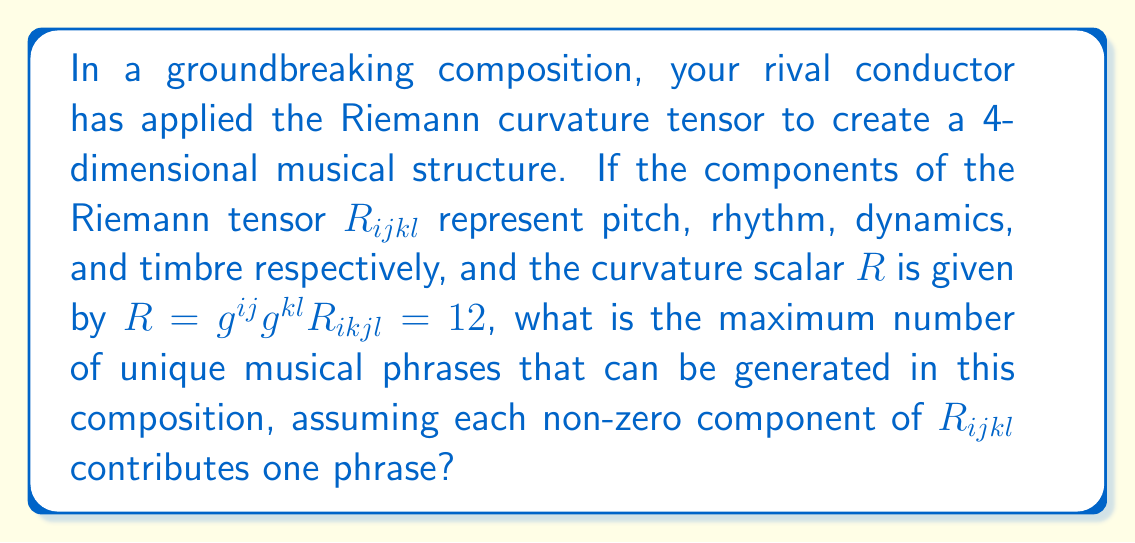Can you solve this math problem? To solve this problem, we need to follow these steps:

1) Recall that the Riemann curvature tensor $R_{ijkl}$ in 4 dimensions has 256 components (4^4).

2) However, due to the symmetries of the Riemann tensor:
   $R_{ijkl} = -R_{jikl} = -R_{ijlk} = R_{klij}$

3) These symmetries reduce the number of independent components to:
   $\frac{1}{12}n^2(n^2-1)$ where n is the dimension (4 in this case).

4) Calculate the number of independent components:
   $\frac{1}{12}4^2(4^2-1) = \frac{1}{12}16(15) = 20$

5) The curvature scalar $R = 12$ implies that not all components are zero, but it doesn't specify how many are non-zero.

6) In the worst-case scenario for our envious persona (maximum uniqueness for the rival), all 20 independent components could be non-zero.

7) Therefore, the maximum number of unique musical phrases that can be generated is 20.
Answer: 20 unique phrases 